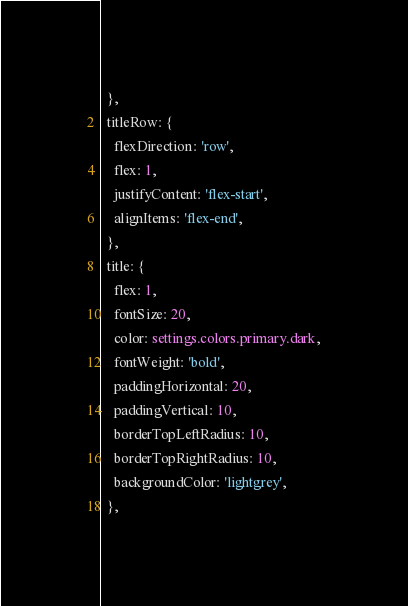<code> <loc_0><loc_0><loc_500><loc_500><_TypeScript_>  },
  titleRow: {
    flexDirection: 'row',
    flex: 1,
    justifyContent: 'flex-start',
    alignItems: 'flex-end',
  },
  title: {
    flex: 1,
    fontSize: 20,
    color: settings.colors.primary.dark,
    fontWeight: 'bold',
    paddingHorizontal: 20,
    paddingVertical: 10,
    borderTopLeftRadius: 10,
    borderTopRightRadius: 10,
    backgroundColor: 'lightgrey',
  },</code> 